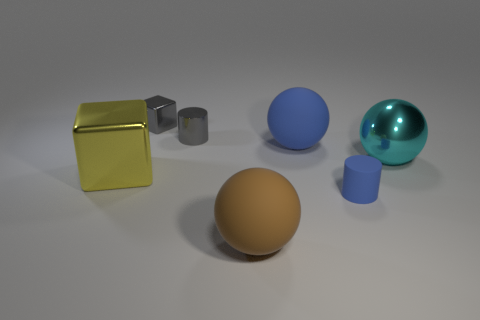Are any tiny purple rubber things visible?
Offer a terse response. No. The cylinder behind the large object that is on the right side of the matte ball right of the brown ball is what color?
Your answer should be compact. Gray. There is a large object that is in front of the tiny rubber object; are there any objects behind it?
Offer a very short reply. Yes. There is a cylinder that is on the right side of the small gray metal cylinder; is it the same color as the large matte ball behind the big yellow metallic cube?
Your response must be concise. Yes. How many gray metallic things are the same size as the gray shiny block?
Provide a succinct answer. 1. There is a cyan thing that is to the right of the yellow block; does it have the same size as the big blue sphere?
Give a very brief answer. Yes. The big yellow shiny thing has what shape?
Your response must be concise. Cube. There is a thing that is the same color as the small metallic cube; what is its size?
Your response must be concise. Small. Do the ball that is in front of the yellow object and the tiny blue object have the same material?
Give a very brief answer. Yes. Are there any balls that have the same color as the big metallic block?
Your answer should be very brief. No. 